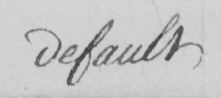What is written in this line of handwriting? default 